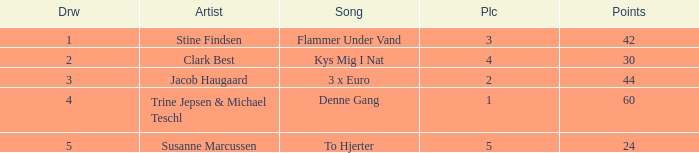What is the lowest Draw when the Artist is Stine Findsen and the Points are larger than 42? None. 